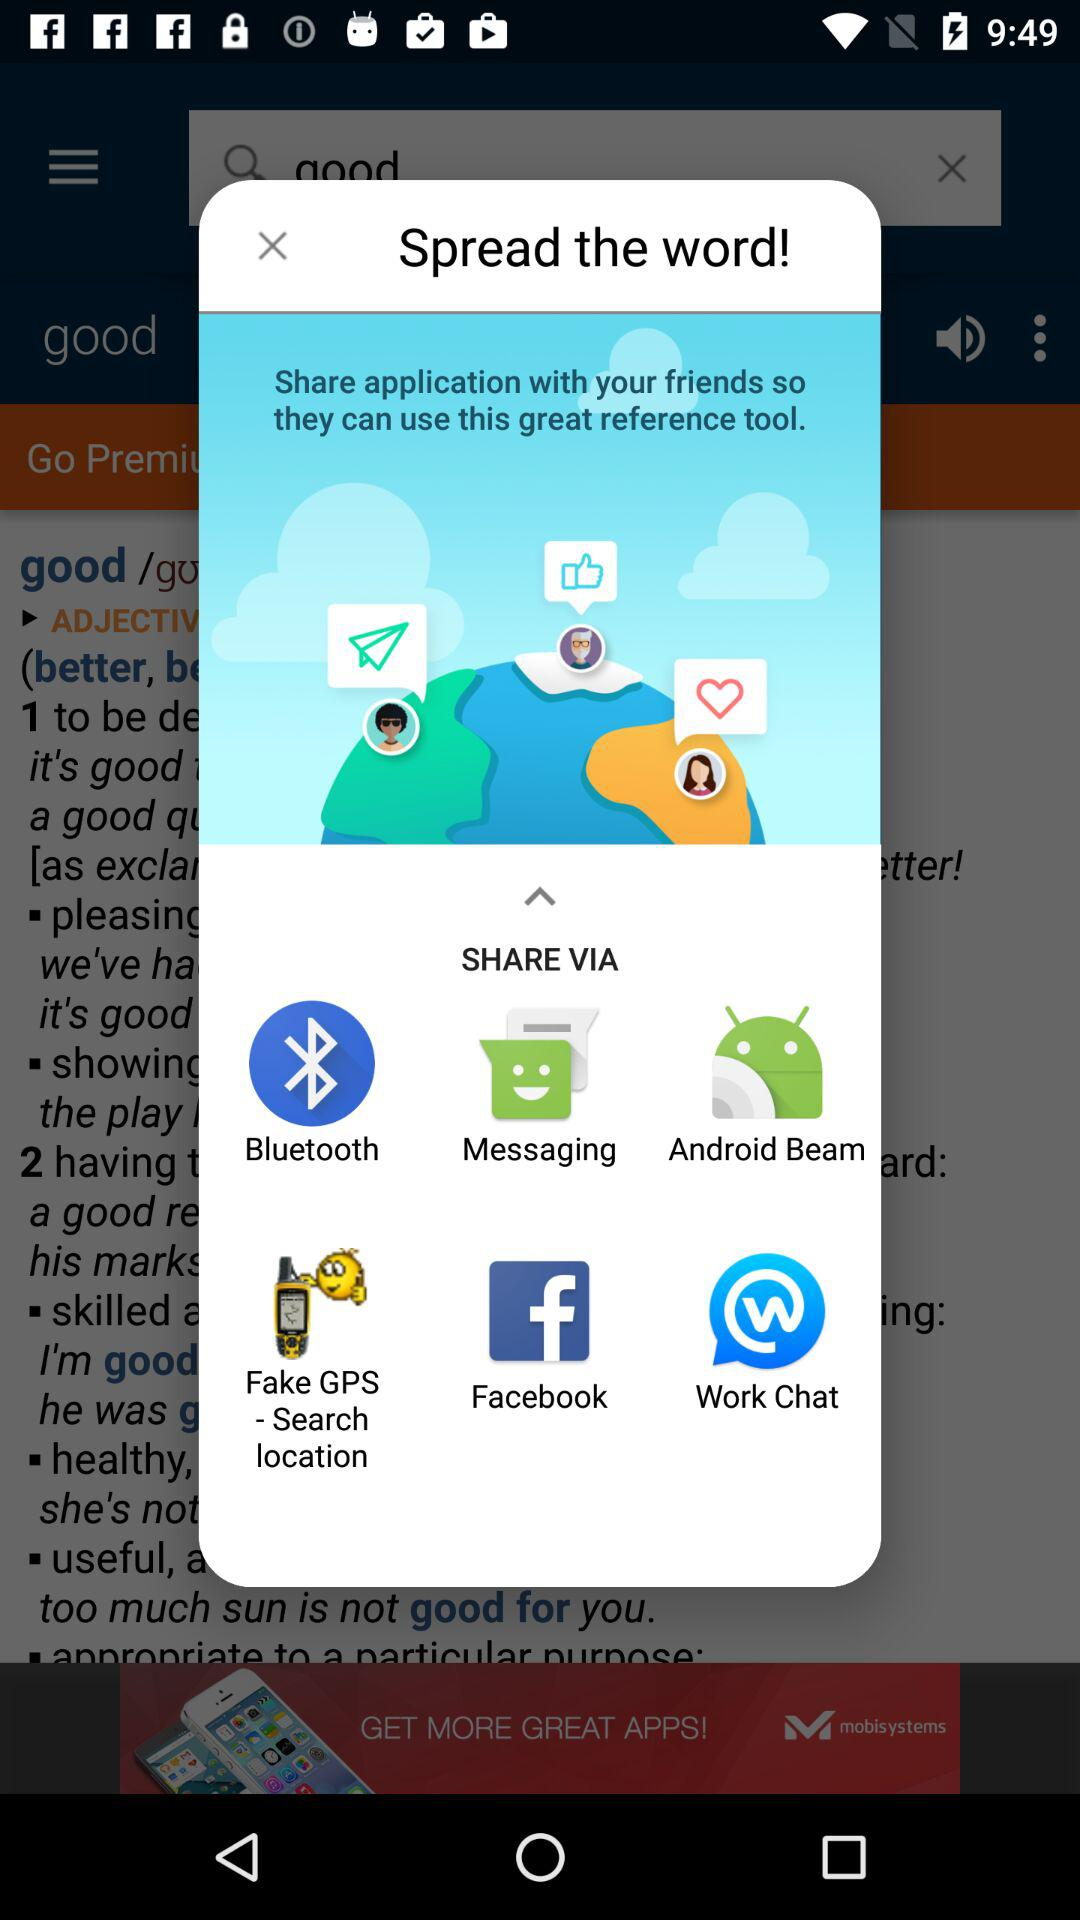What applications can be used to share? The applications that can be used to share are "Bluetooth", "Messaging", "Android Beam", "Fake GPS - Search location", "Facebook" and "Work Chat". 